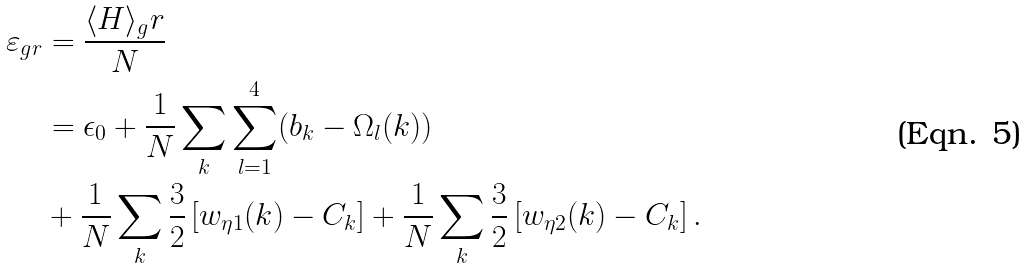<formula> <loc_0><loc_0><loc_500><loc_500>\varepsilon _ { g r } & = \frac { \langle H \rangle _ { g } r } { N } \\ & = \epsilon _ { 0 } + \frac { 1 } { N } \sum _ { k } \sum _ { l = 1 } ^ { 4 } ( b _ { k } - \Omega _ { l } ( k ) ) \\ & + \frac { 1 } { N } \sum _ { k } \frac { 3 } { 2 } \left [ w _ { \eta 1 } ( k ) - C _ { k } \right ] + \frac { 1 } { N } \sum _ { k } \frac { 3 } { 2 } \left [ w _ { \eta 2 } ( k ) - C _ { k } \right ] .</formula> 